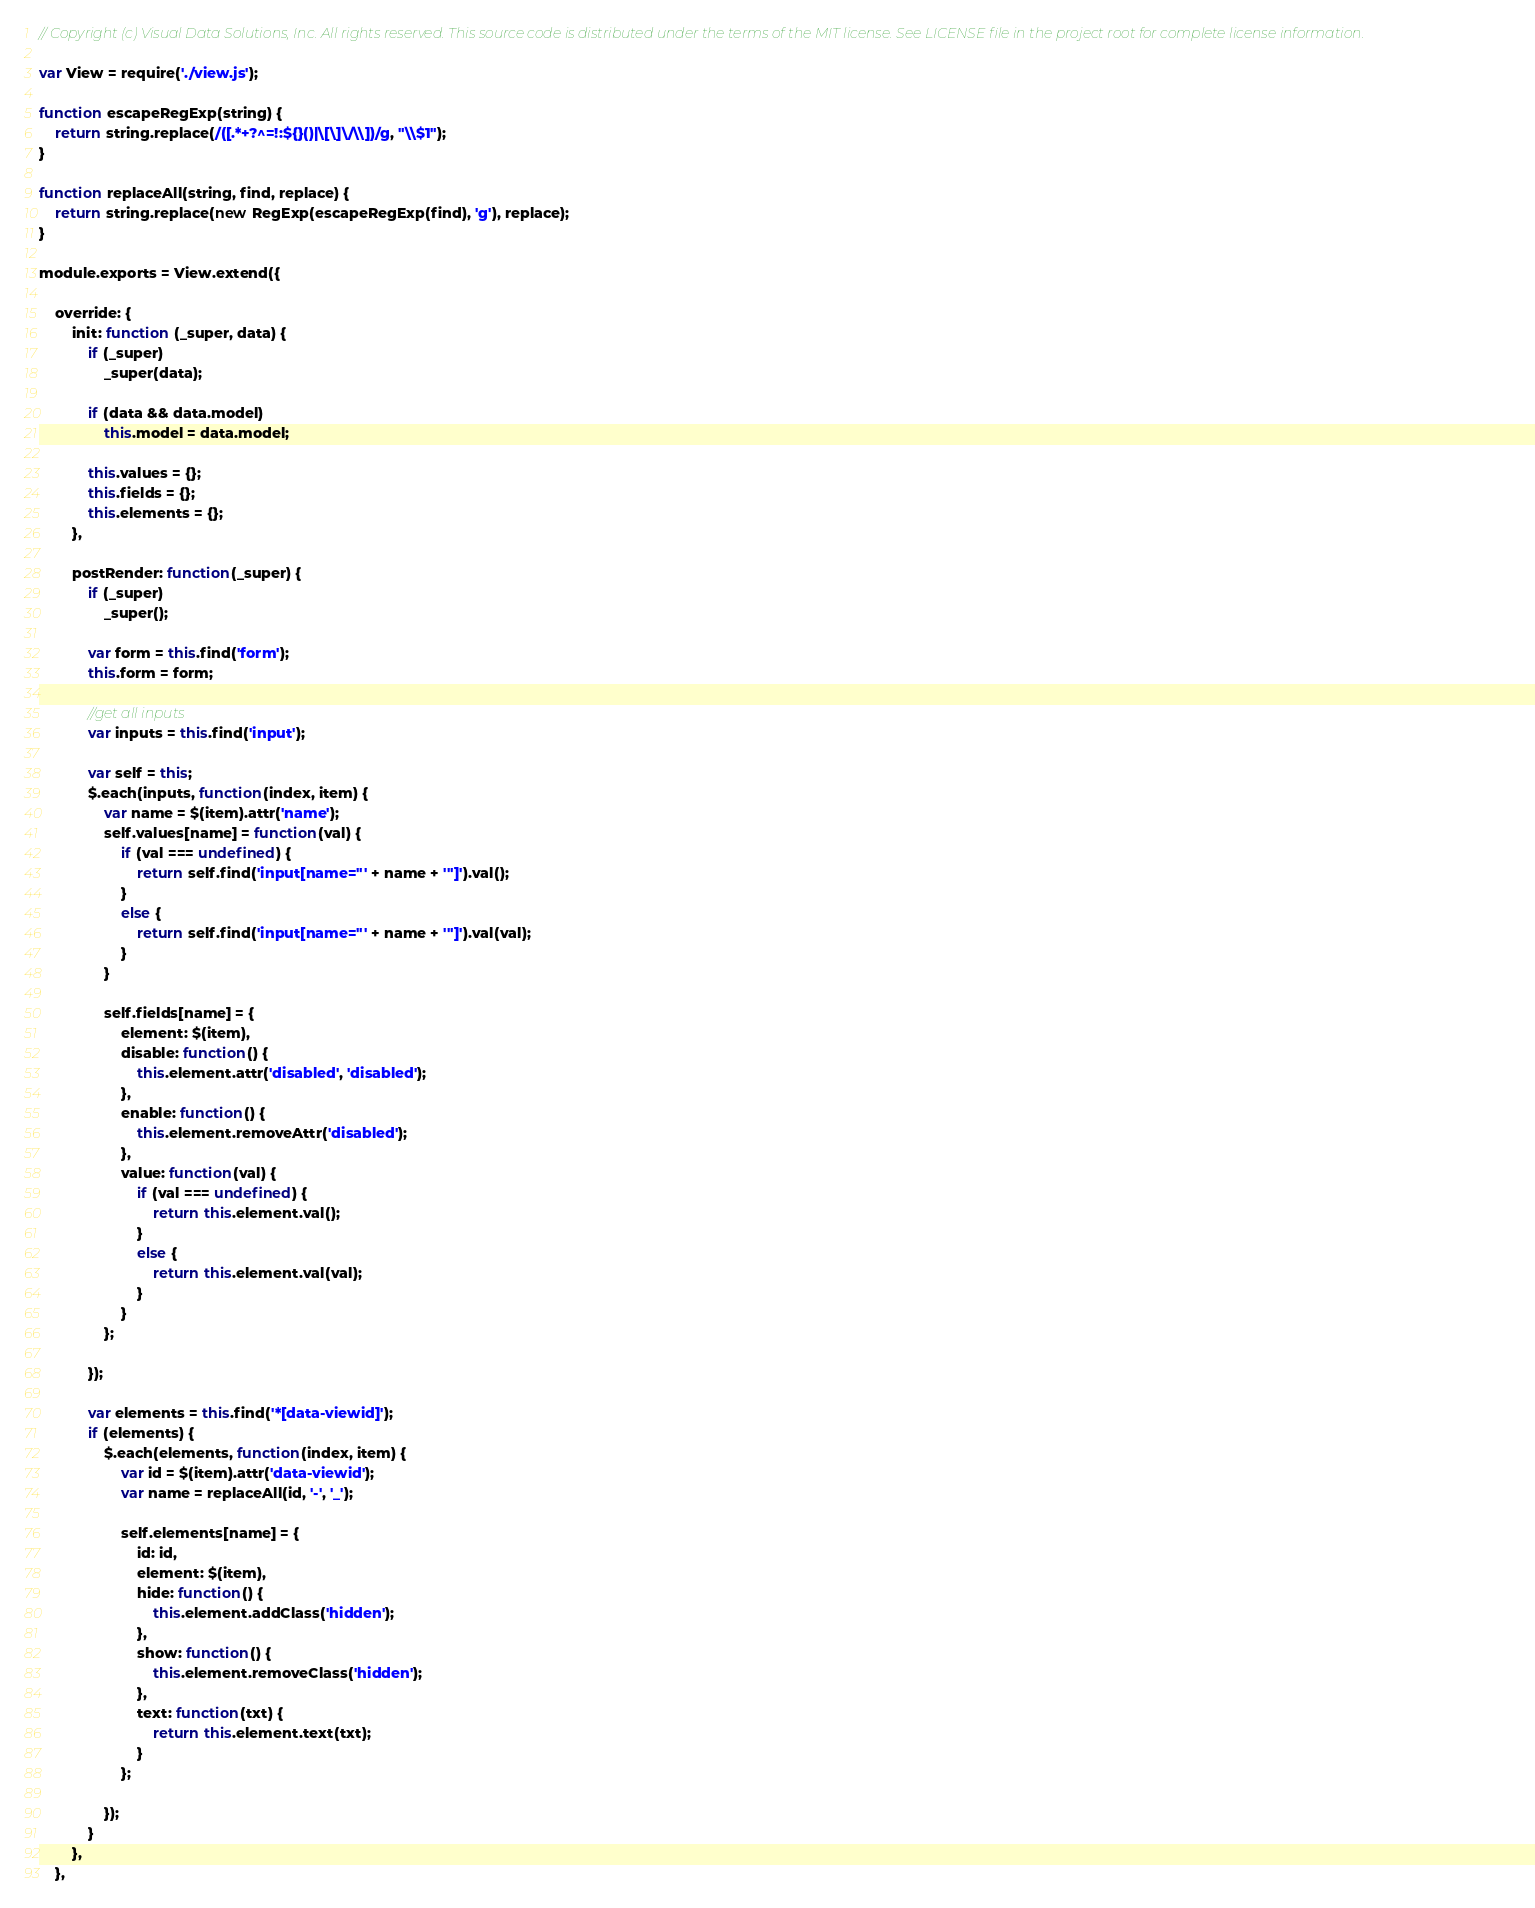<code> <loc_0><loc_0><loc_500><loc_500><_JavaScript_>// Copyright (c) Visual Data Solutions, Inc. All rights reserved. This source code is distributed under the terms of the MIT license. See LICENSE file in the project root for complete license information.

var View = require('./view.js');

function escapeRegExp(string) {
    return string.replace(/([.*+?^=!:${}()|\[\]\/\\])/g, "\\$1");
}

function replaceAll(string, find, replace) {
    return string.replace(new RegExp(escapeRegExp(find), 'g'), replace);
}

module.exports = View.extend({

    override: {
        init: function (_super, data) {
            if (_super)
                _super(data);

            if (data && data.model)
                this.model = data.model;

            this.values = {};
            this.fields = {};
            this.elements = {};
        },

        postRender: function(_super) {
            if (_super)
                _super();

            var form = this.find('form');
            this.form = form;

            //get all inputs
            var inputs = this.find('input');

            var self = this;
            $.each(inputs, function(index, item) {
                var name = $(item).attr('name');
                self.values[name] = function(val) {
                    if (val === undefined) {
                        return self.find('input[name="' + name + '"]').val();
                    }
                    else {
                        return self.find('input[name="' + name + '"]').val(val);
                    }
                }

                self.fields[name] = {
                    element: $(item),
                    disable: function() {
                        this.element.attr('disabled', 'disabled');
                    },
                    enable: function() {
                        this.element.removeAttr('disabled');
                    },
                    value: function(val) {
                        if (val === undefined) {
                            return this.element.val();
                        }
                        else {
                            return this.element.val(val);
                        }
                    }
                };

            });

            var elements = this.find('*[data-viewid]');
            if (elements) {
                $.each(elements, function(index, item) {
                    var id = $(item).attr('data-viewid');
                    var name = replaceAll(id, '-', '_');

                    self.elements[name] = {
                        id: id,
                        element: $(item),
                        hide: function() {
                            this.element.addClass('hidden');
                        },
                        show: function() {
                            this.element.removeClass('hidden');
                        },
                        text: function(txt) {
                            return this.element.text(txt);
                        }
                    };

                });
            }
        },
    },
</code> 